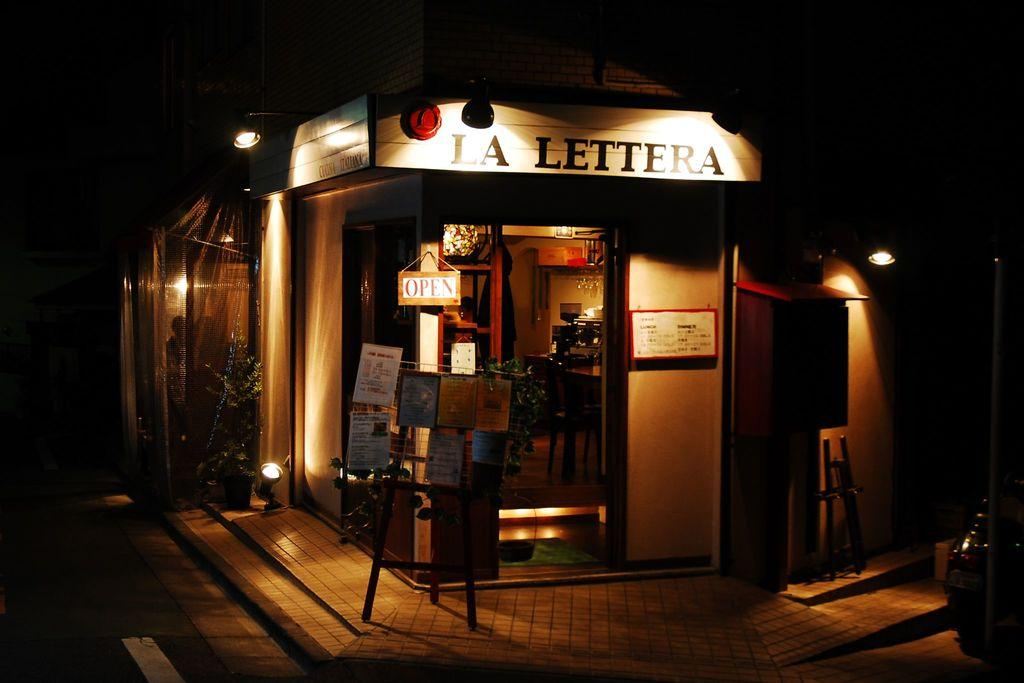Provide a one-sentence caption for the provided image. The corner of a street with a store name La Lettera which is currently open. 